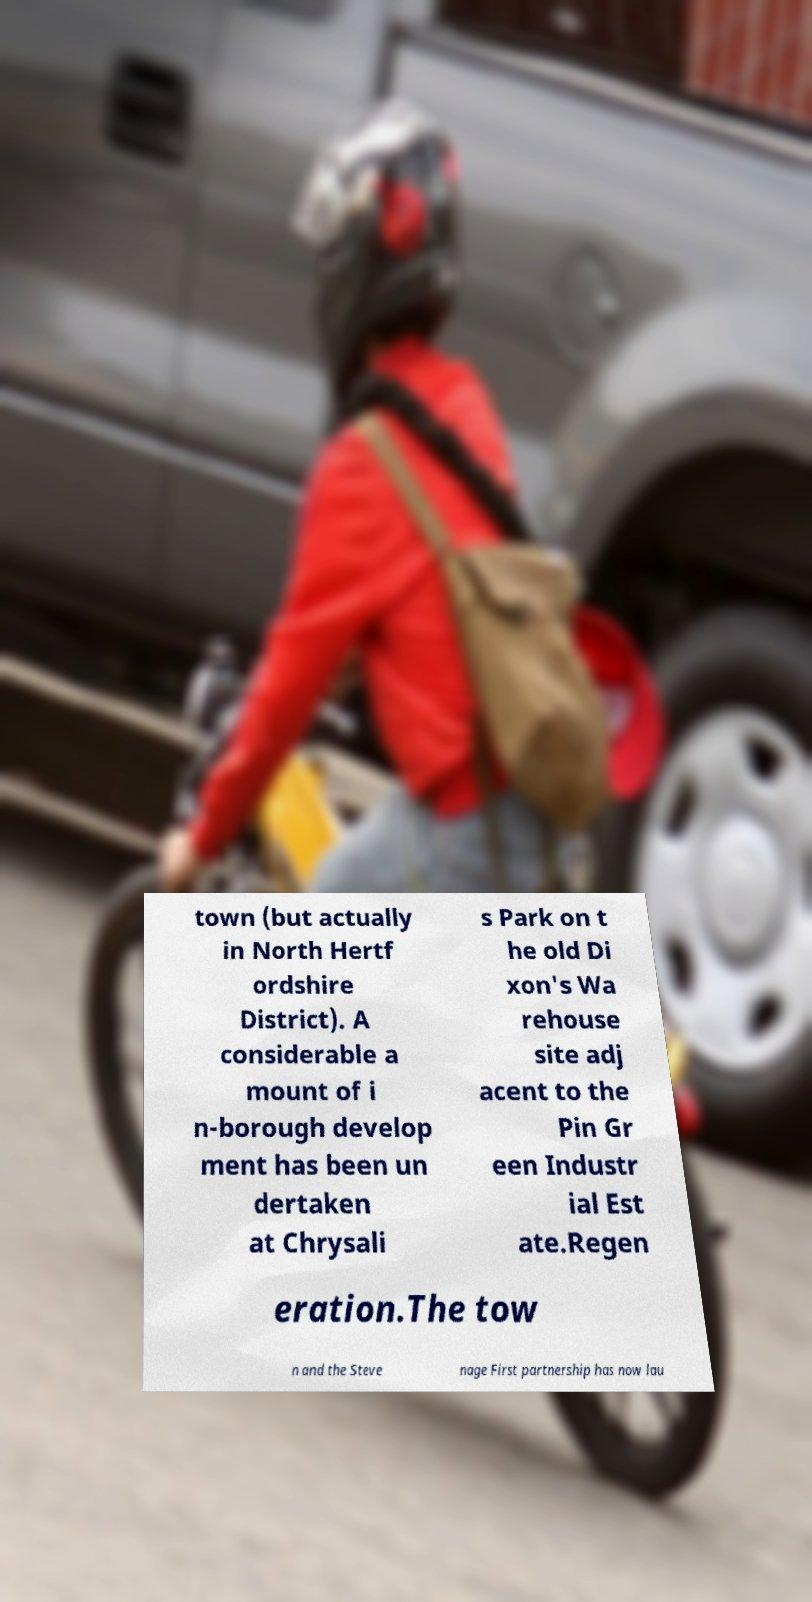There's text embedded in this image that I need extracted. Can you transcribe it verbatim? town (but actually in North Hertf ordshire District). A considerable a mount of i n-borough develop ment has been un dertaken at Chrysali s Park on t he old Di xon's Wa rehouse site adj acent to the Pin Gr een Industr ial Est ate.Regen eration.The tow n and the Steve nage First partnership has now lau 